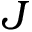Convert formula to latex. <formula><loc_0><loc_0><loc_500><loc_500>J</formula> 